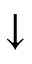<formula> <loc_0><loc_0><loc_500><loc_500>\downarrow</formula> 